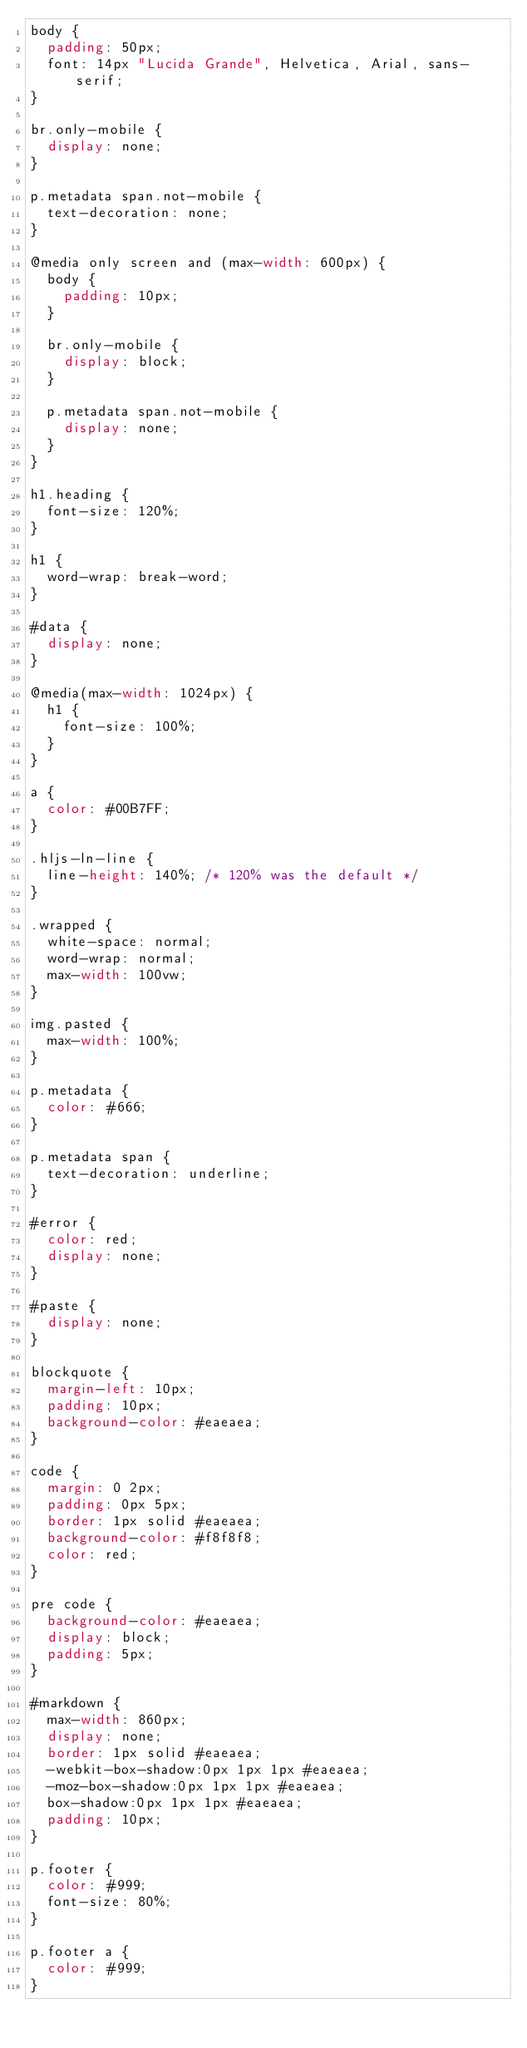<code> <loc_0><loc_0><loc_500><loc_500><_CSS_>body {
  padding: 50px;
  font: 14px "Lucida Grande", Helvetica, Arial, sans-serif;
}

br.only-mobile {
  display: none;
}

p.metadata span.not-mobile {
  text-decoration: none;
}

@media only screen and (max-width: 600px) {
  body {
    padding: 10px;
  }

  br.only-mobile {
    display: block;
  }

  p.metadata span.not-mobile {
    display: none;
  }
}

h1.heading {
  font-size: 120%;
}

h1 {
  word-wrap: break-word;
}

#data {
  display: none;
}

@media(max-width: 1024px) {
  h1 {
    font-size: 100%;
  }
}

a {
  color: #00B7FF;
}

.hljs-ln-line {
  line-height: 140%; /* 120% was the default */
}

.wrapped {
  white-space: normal;
  word-wrap: normal;
  max-width: 100vw;
}

img.pasted {
  max-width: 100%;
}

p.metadata {
  color: #666;
}

p.metadata span {
  text-decoration: underline;
}

#error {
  color: red;
  display: none;
}

#paste {
  display: none;
}

blockquote {
  margin-left: 10px;
  padding: 10px;
  background-color: #eaeaea;
}

code {
  margin: 0 2px;
  padding: 0px 5px;
  border: 1px solid #eaeaea;
  background-color: #f8f8f8;
  color: red;
}

pre code {
  background-color: #eaeaea;
  display: block;
  padding: 5px;
}

#markdown {
  max-width: 860px;
  display: none;
  border: 1px solid #eaeaea;
  -webkit-box-shadow:0px 1px 1px #eaeaea;
  -moz-box-shadow:0px 1px 1px #eaeaea;
  box-shadow:0px 1px 1px #eaeaea;
  padding: 10px;
}

p.footer {
  color: #999;
  font-size: 80%;
}

p.footer a {
  color: #999;
}
</code> 